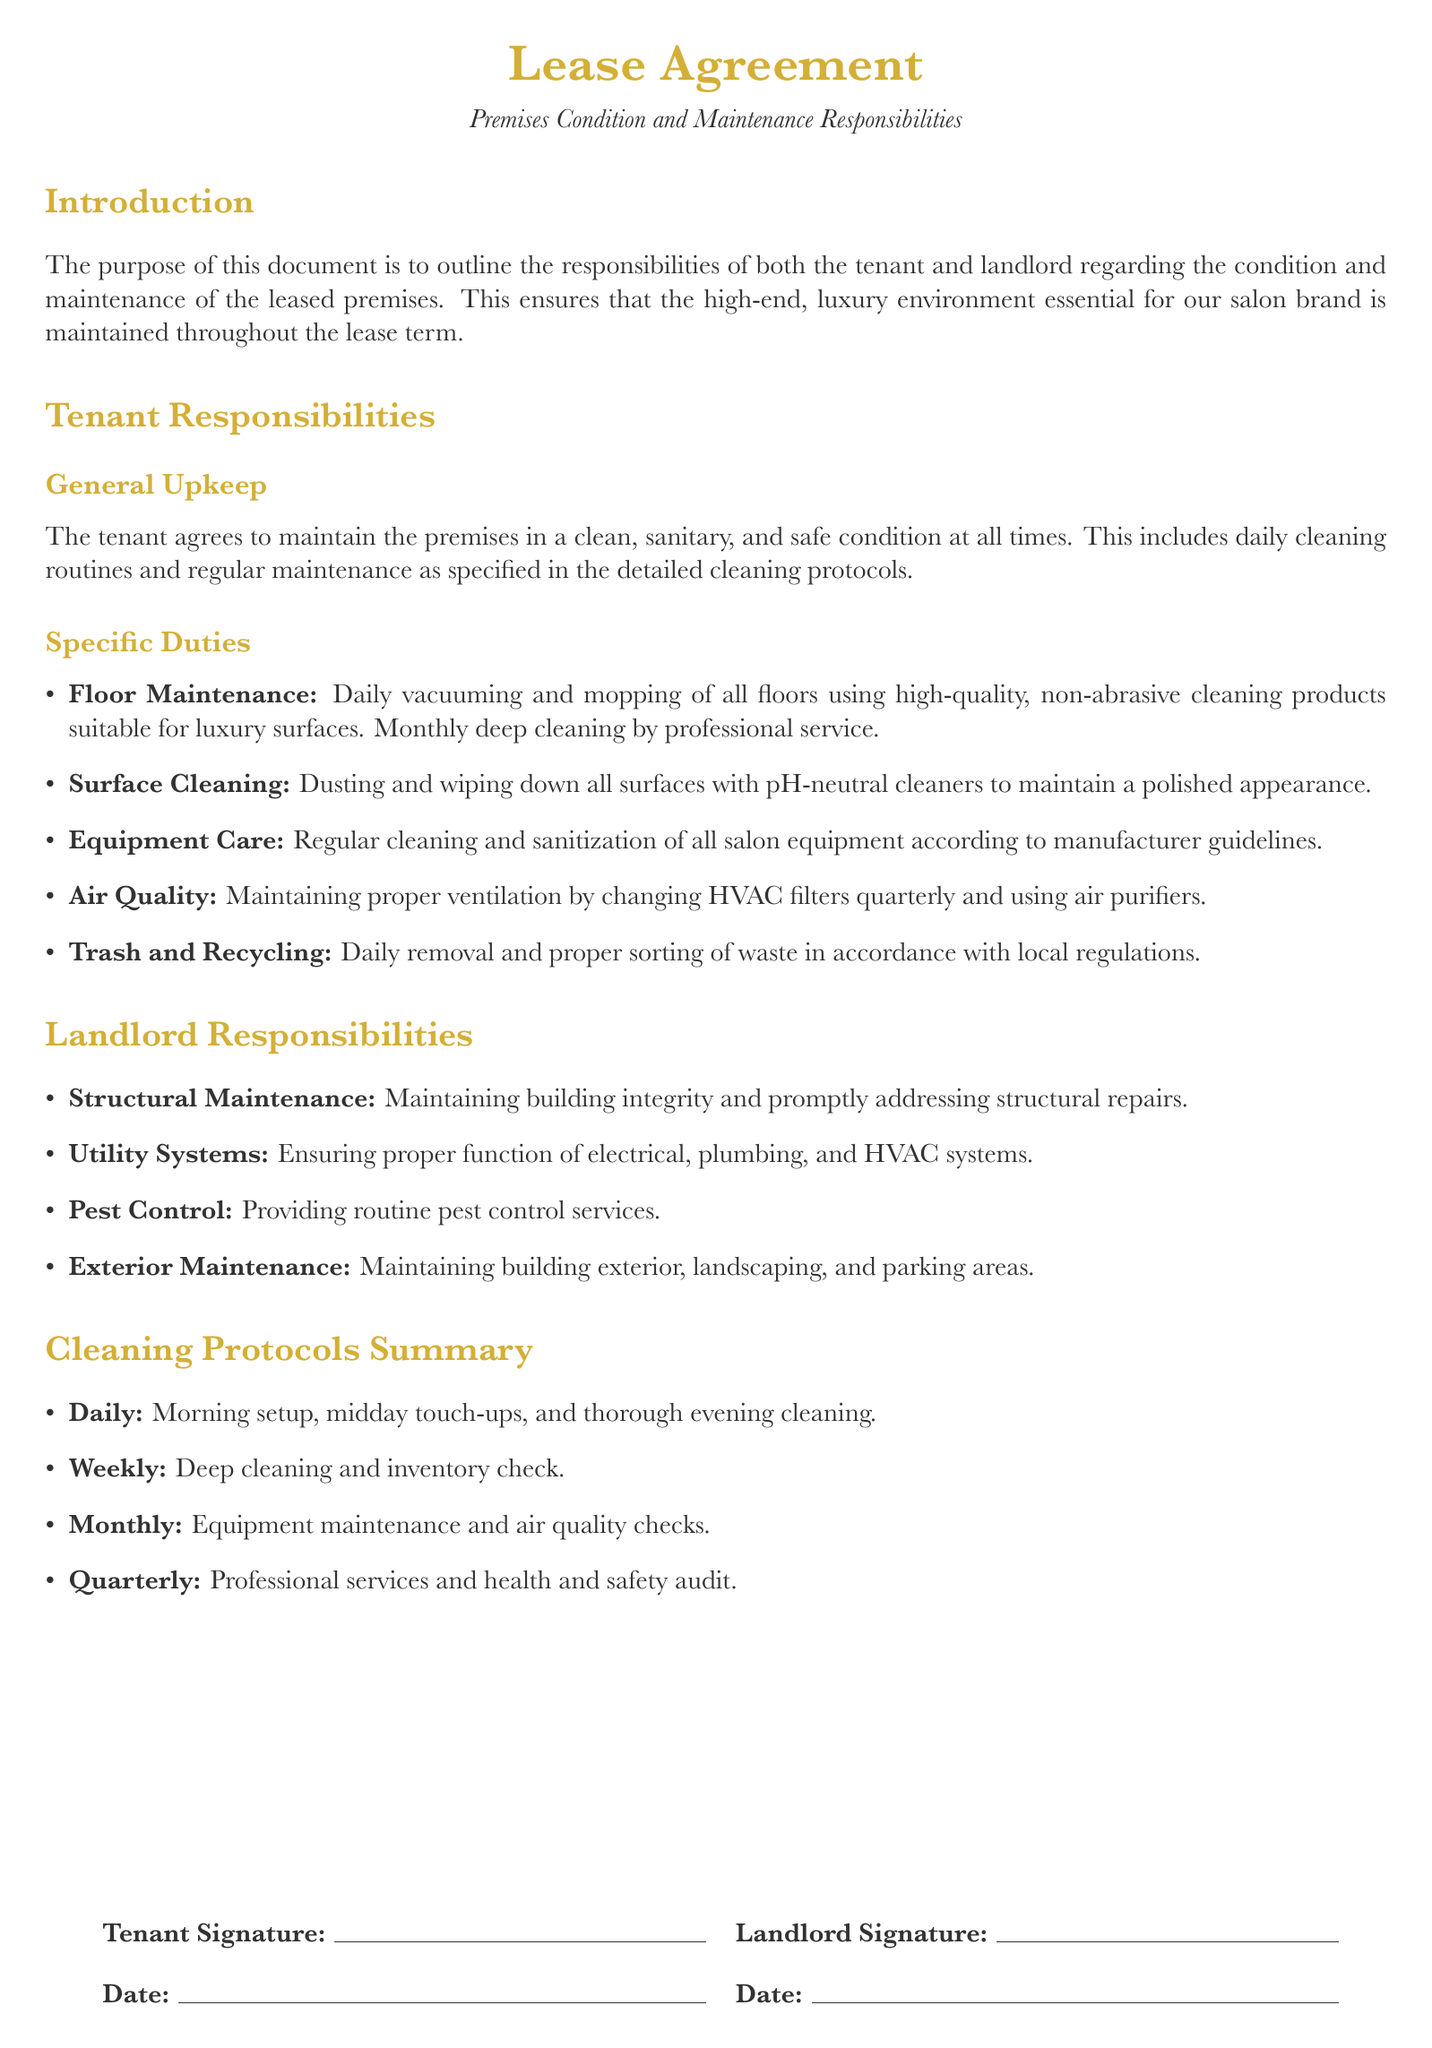What are the tenant's general upkeep responsibilities? The tenant's general upkeep responsibilities include maintaining the premises in a clean, sanitary, and safe condition at all times.
Answer: Clean, sanitary, safe condition What specific cleaning routine is required for floors? The document specifies daily vacuuming and mopping of all floors using non-abrasive cleaning products.
Answer: Daily vacuuming and mopping How often should HVAC filters be changed? The tenant is responsible for changing HVAC filters quarterly to maintain proper ventilation.
Answer: Quarterly Who is responsible for pest control services? The landlord is responsible for providing routine pest control services as outlined in the lease agreement.
Answer: Landlord What is included in the monthly maintenance checklist? The monthly maintenance checklist includes equipment maintenance and air quality checks.
Answer: Equipment maintenance and air quality checks What type of cleaners should be used on surfaces? The tenant is required to use pH-neutral cleaners for dusting and wiping down all surfaces.
Answer: pH-neutral cleaners What is the color used for section titles? The color used for section titles in the document is gold accent.
Answer: Gold accent How frequently should deep cleaning be performed? The tenant is required to perform deep cleaning weekly, according to the cleaning protocols.
Answer: Weekly What is the purpose of this document? The purpose of this document is to outline the responsibilities of both the tenant and landlord.
Answer: Outline responsibilities 